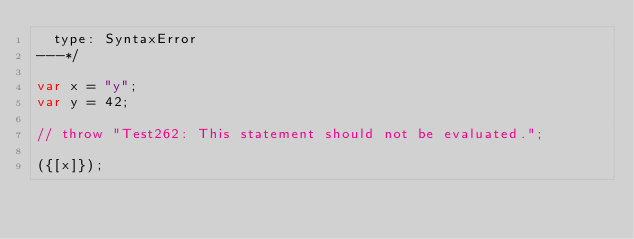Convert code to text. <code><loc_0><loc_0><loc_500><loc_500><_JavaScript_>  type: SyntaxError
---*/

var x = "y";
var y = 42;

// throw "Test262: This statement should not be evaluated.";

({[x]});
</code> 